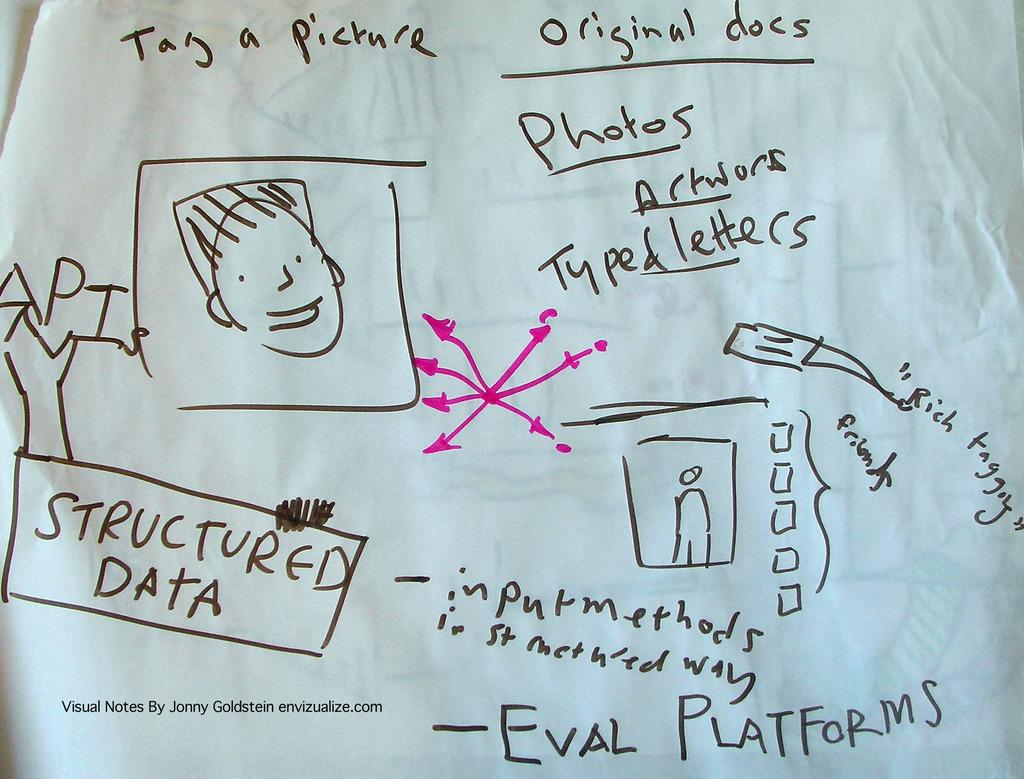What is present on the paper in the image? There is a paper in the image, and it has text written on it. Are there any illustrations or images on the paper? Yes, there are pictures on the paper that resemble a person. How many wings does the person depicted on the paper have? There is no person with wings depicted on the paper; it only shows a person without wings. 